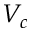<formula> <loc_0><loc_0><loc_500><loc_500>V _ { c }</formula> 